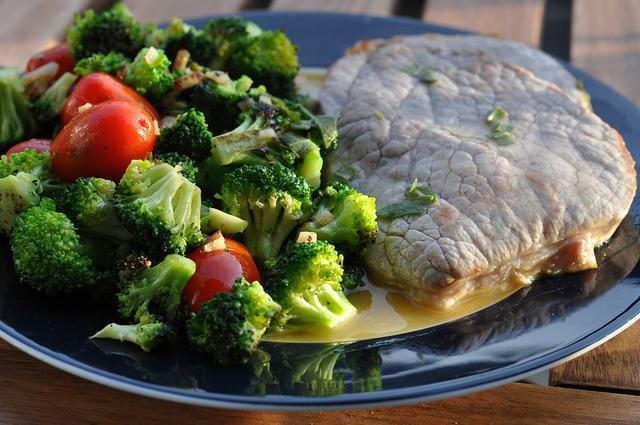How many broccolis are in the picture?
Give a very brief answer. 6. How many elephants are to the right of another elephant?
Give a very brief answer. 0. 